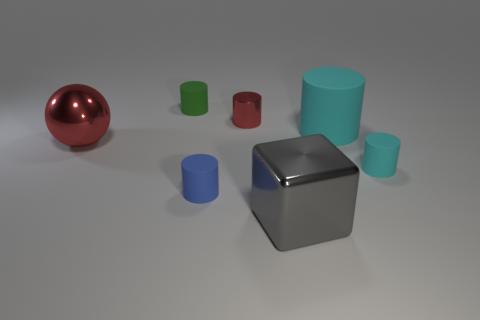Subtract all large cyan cylinders. How many cylinders are left? 4 Subtract 1 cylinders. How many cylinders are left? 4 Subtract all blue cylinders. How many cylinders are left? 4 Subtract all gray cylinders. Subtract all purple blocks. How many cylinders are left? 5 Add 2 large cyan cylinders. How many objects exist? 9 Subtract all blocks. How many objects are left? 6 Add 4 small red cylinders. How many small red cylinders are left? 5 Add 7 red things. How many red things exist? 9 Subtract 0 blue spheres. How many objects are left? 7 Subtract all red metal objects. Subtract all purple matte spheres. How many objects are left? 5 